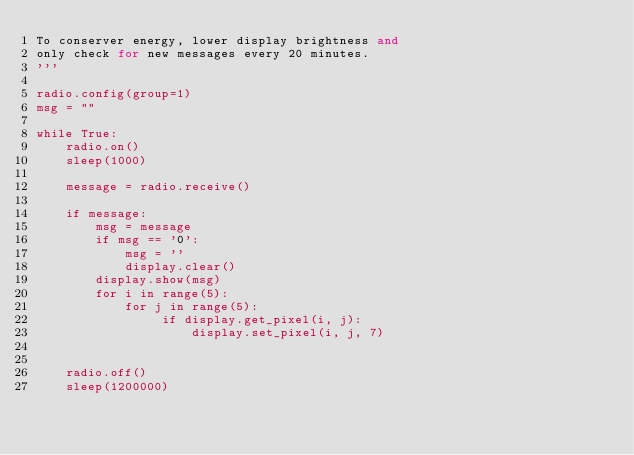<code> <loc_0><loc_0><loc_500><loc_500><_Python_>To conserver energy, lower display brightness and 
only check for new messages every 20 minutes. 
'''    

radio.config(group=1)
msg = ""

while True:
    radio.on()
    sleep(1000)

    message = radio.receive()

    if message:
        msg = message
        if msg == '0':
            msg = ''
            display.clear()
        display.show(msg)
        for i in range(5):
            for j in range(5):
                 if display.get_pixel(i, j):
                     display.set_pixel(i, j, 7)
        

    radio.off()
    sleep(1200000)</code> 